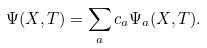Convert formula to latex. <formula><loc_0><loc_0><loc_500><loc_500>\Psi ( { X } , T ) = \sum _ { a } c _ { a } \Psi _ { a } ( { X } , T ) .</formula> 